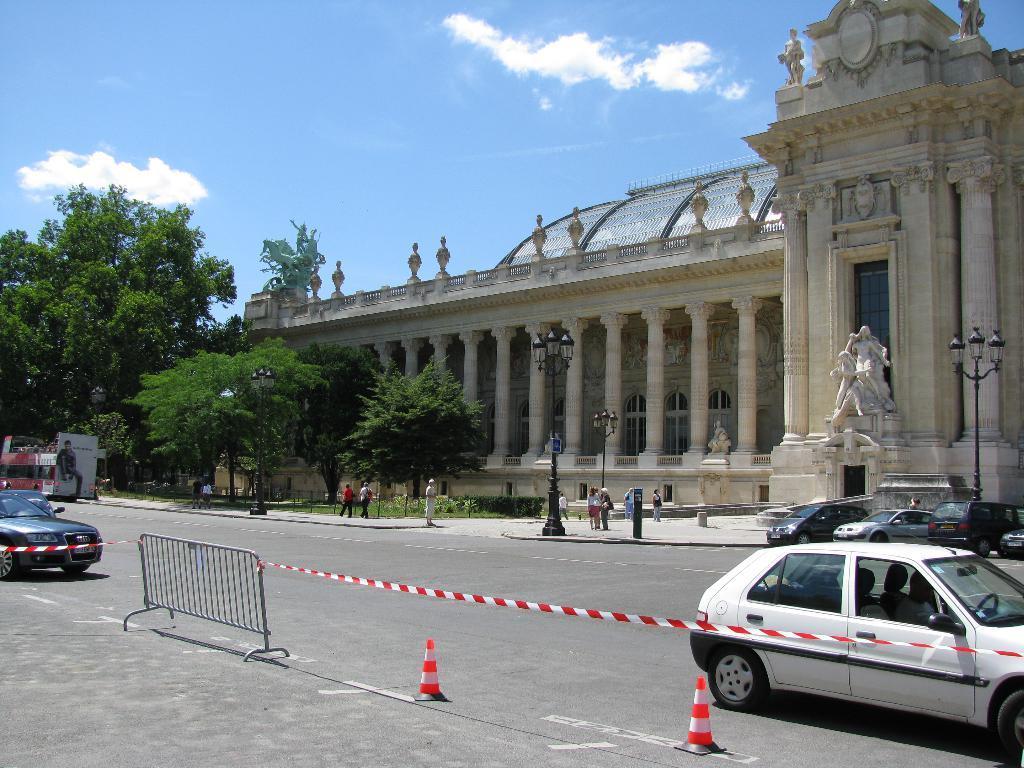Please provide a concise description of this image. In this image there is a building with sculptures and an arched roof at the top, there are few vehicles and people on the road, few trees, a fence, lights to the poles, sculptures of persons on a block and some clouds in the sky. 